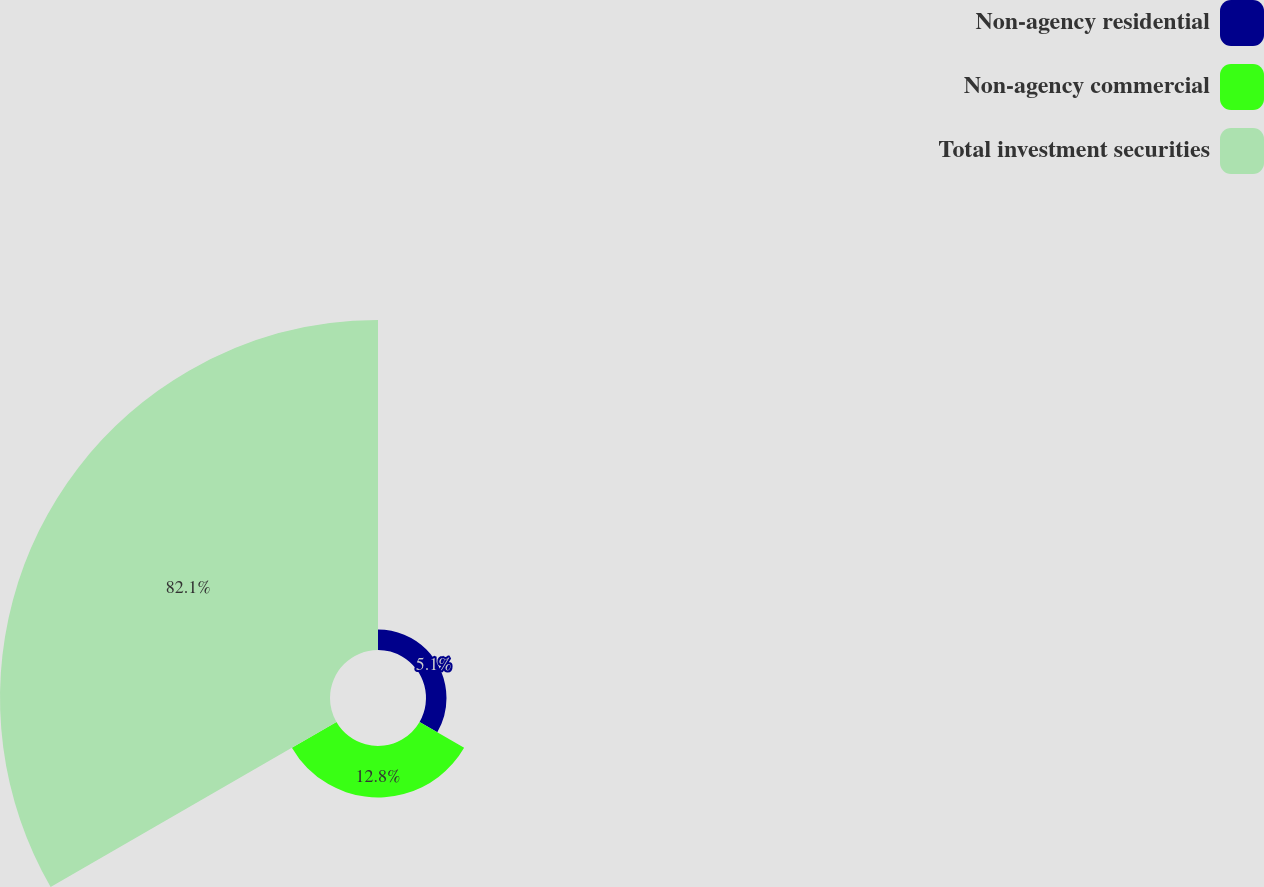Convert chart to OTSL. <chart><loc_0><loc_0><loc_500><loc_500><pie_chart><fcel>Non-agency residential<fcel>Non-agency commercial<fcel>Total investment securities<nl><fcel>5.1%<fcel>12.8%<fcel>82.11%<nl></chart> 